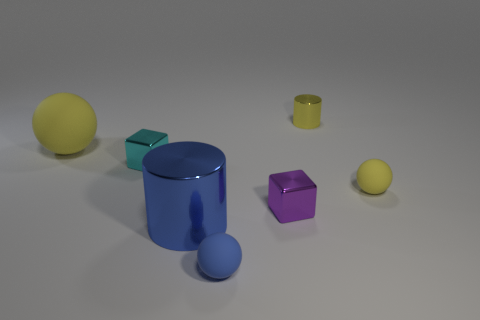Add 3 small yellow metallic objects. How many objects exist? 10 Subtract all cylinders. How many objects are left? 5 Subtract 0 brown balls. How many objects are left? 7 Subtract all blue cylinders. Subtract all tiny purple objects. How many objects are left? 5 Add 1 large things. How many large things are left? 3 Add 2 big metallic objects. How many big metallic objects exist? 3 